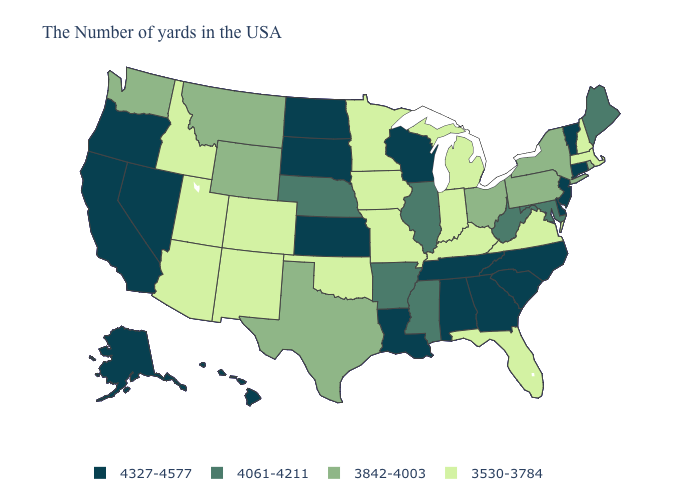Does the map have missing data?
Write a very short answer. No. Does South Carolina have a higher value than California?
Give a very brief answer. No. Name the states that have a value in the range 4061-4211?
Write a very short answer. Maine, Maryland, West Virginia, Illinois, Mississippi, Arkansas, Nebraska. Name the states that have a value in the range 3842-4003?
Concise answer only. Rhode Island, New York, Pennsylvania, Ohio, Texas, Wyoming, Montana, Washington. Among the states that border Tennessee , does Kentucky have the highest value?
Quick response, please. No. Is the legend a continuous bar?
Write a very short answer. No. Which states have the lowest value in the West?
Short answer required. Colorado, New Mexico, Utah, Arizona, Idaho. Does Mississippi have a higher value than Georgia?
Give a very brief answer. No. Does Wyoming have the highest value in the West?
Write a very short answer. No. Name the states that have a value in the range 3842-4003?
Quick response, please. Rhode Island, New York, Pennsylvania, Ohio, Texas, Wyoming, Montana, Washington. What is the lowest value in the Northeast?
Give a very brief answer. 3530-3784. Does the map have missing data?
Short answer required. No. What is the value of Mississippi?
Give a very brief answer. 4061-4211. Name the states that have a value in the range 4061-4211?
Answer briefly. Maine, Maryland, West Virginia, Illinois, Mississippi, Arkansas, Nebraska. Which states have the highest value in the USA?
Keep it brief. Vermont, Connecticut, New Jersey, Delaware, North Carolina, South Carolina, Georgia, Alabama, Tennessee, Wisconsin, Louisiana, Kansas, South Dakota, North Dakota, Nevada, California, Oregon, Alaska, Hawaii. 